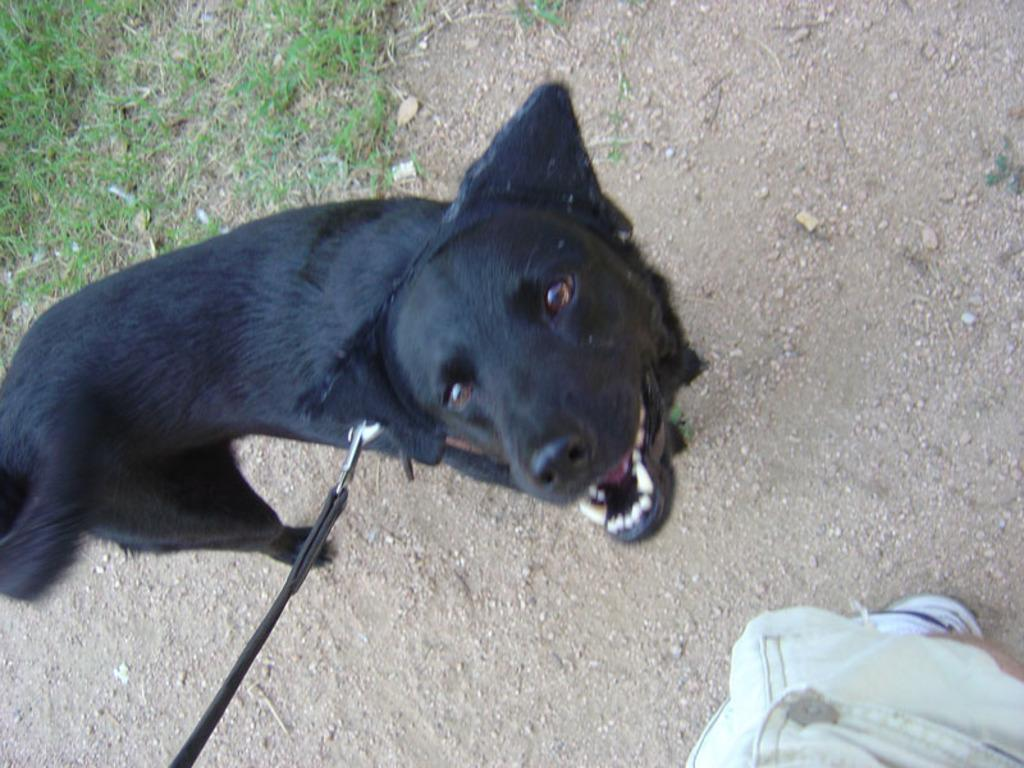What type of animal is in the image? There is a black dog in the image. How is the dog being controlled or restrained in the image? The dog has a leash in the image. What type of terrain is visible in the image? There is grass visible in the image. How is the grass depicted in the image? The grass is truncated towards the left of the image. Can you identify any other living being in the image? Yes, there is a person visible in the image. How is the person depicted in the image? The person is truncated towards the left of the image. What type of monkey can be seen playing with a stem in the image? There is no monkey or stem present in the image; it features a black dog with a leash, grass, and a person. 